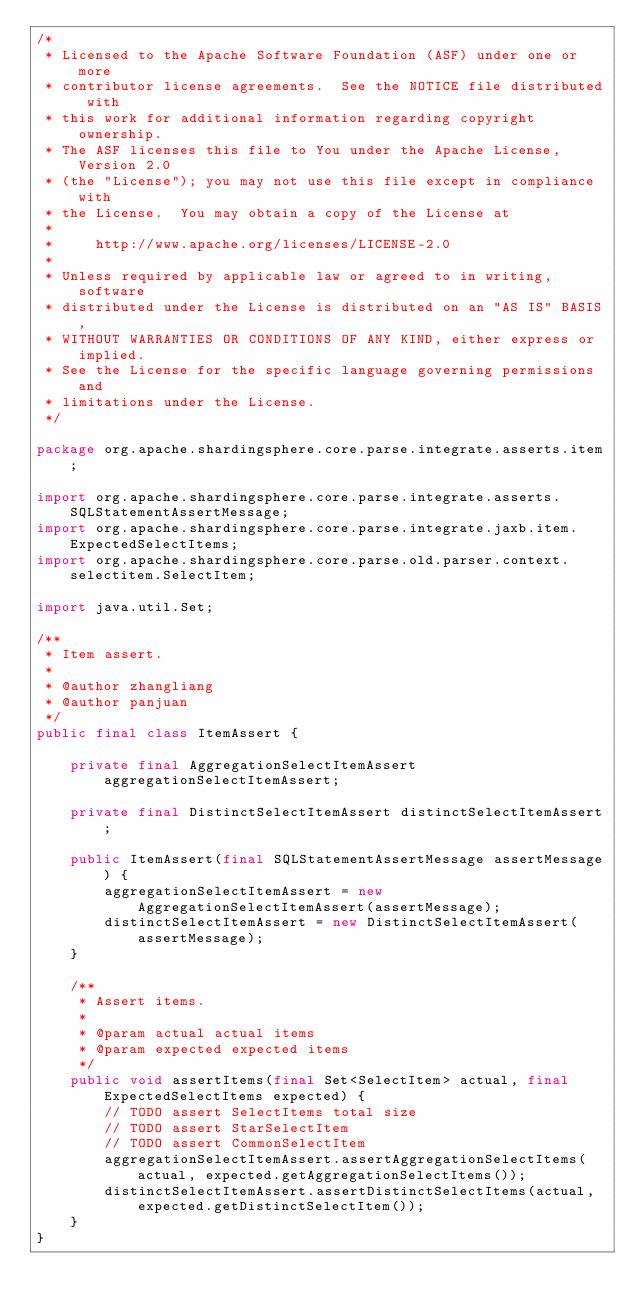<code> <loc_0><loc_0><loc_500><loc_500><_Java_>/*
 * Licensed to the Apache Software Foundation (ASF) under one or more
 * contributor license agreements.  See the NOTICE file distributed with
 * this work for additional information regarding copyright ownership.
 * The ASF licenses this file to You under the Apache License, Version 2.0
 * (the "License"); you may not use this file except in compliance with
 * the License.  You may obtain a copy of the License at
 *
 *     http://www.apache.org/licenses/LICENSE-2.0
 *
 * Unless required by applicable law or agreed to in writing, software
 * distributed under the License is distributed on an "AS IS" BASIS,
 * WITHOUT WARRANTIES OR CONDITIONS OF ANY KIND, either express or implied.
 * See the License for the specific language governing permissions and
 * limitations under the License.
 */

package org.apache.shardingsphere.core.parse.integrate.asserts.item;

import org.apache.shardingsphere.core.parse.integrate.asserts.SQLStatementAssertMessage;
import org.apache.shardingsphere.core.parse.integrate.jaxb.item.ExpectedSelectItems;
import org.apache.shardingsphere.core.parse.old.parser.context.selectitem.SelectItem;

import java.util.Set;

/**
 * Item assert.
 *
 * @author zhangliang
 * @author panjuan
 */
public final class ItemAssert {
    
    private final AggregationSelectItemAssert aggregationSelectItemAssert;
    
    private final DistinctSelectItemAssert distinctSelectItemAssert;
    
    public ItemAssert(final SQLStatementAssertMessage assertMessage) {
        aggregationSelectItemAssert = new AggregationSelectItemAssert(assertMessage);
        distinctSelectItemAssert = new DistinctSelectItemAssert(assertMessage);
    }
    
    /**
     * Assert items.
     * 
     * @param actual actual items
     * @param expected expected items
     */
    public void assertItems(final Set<SelectItem> actual, final ExpectedSelectItems expected) {
        // TODO assert SelectItems total size
        // TODO assert StarSelectItem
        // TODO assert CommonSelectItem
        aggregationSelectItemAssert.assertAggregationSelectItems(actual, expected.getAggregationSelectItems());
        distinctSelectItemAssert.assertDistinctSelectItems(actual, expected.getDistinctSelectItem());
    }
}
</code> 